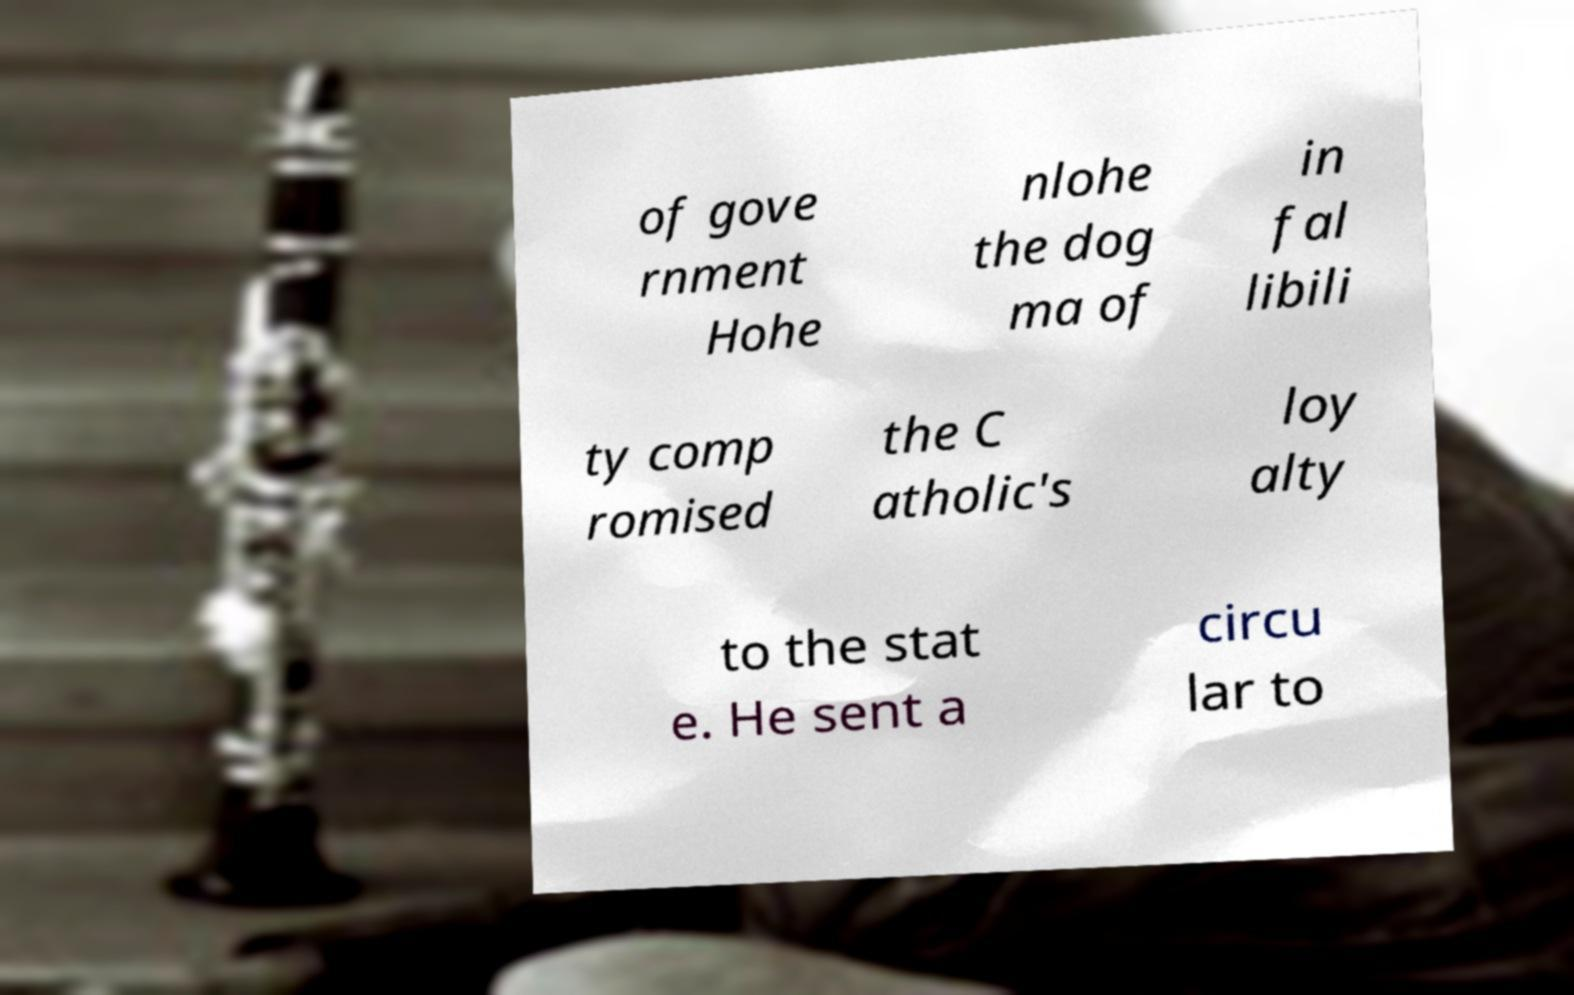What messages or text are displayed in this image? I need them in a readable, typed format. of gove rnment Hohe nlohe the dog ma of in fal libili ty comp romised the C atholic's loy alty to the stat e. He sent a circu lar to 